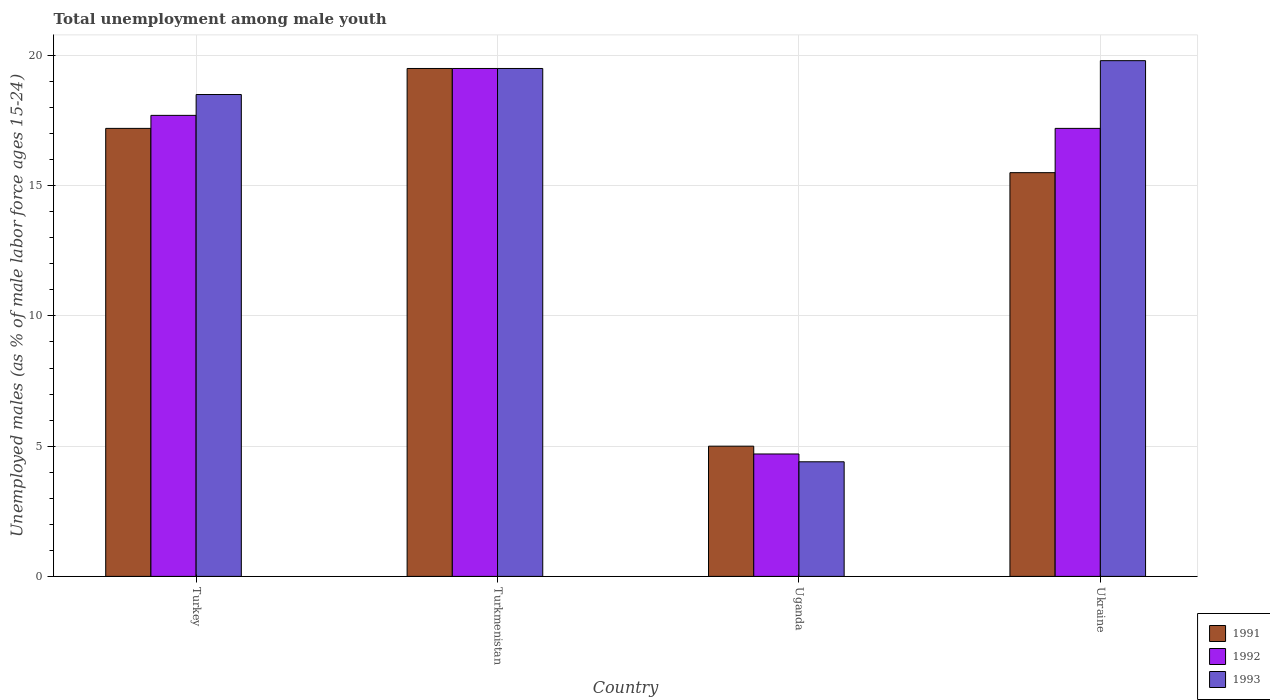How many different coloured bars are there?
Make the answer very short. 3. Are the number of bars per tick equal to the number of legend labels?
Offer a terse response. Yes. What is the label of the 4th group of bars from the left?
Your response must be concise. Ukraine. What is the percentage of unemployed males in in 1993 in Uganda?
Make the answer very short. 4.4. Across all countries, what is the maximum percentage of unemployed males in in 1993?
Your answer should be compact. 19.8. Across all countries, what is the minimum percentage of unemployed males in in 1991?
Give a very brief answer. 5. In which country was the percentage of unemployed males in in 1993 maximum?
Make the answer very short. Ukraine. In which country was the percentage of unemployed males in in 1991 minimum?
Keep it short and to the point. Uganda. What is the total percentage of unemployed males in in 1991 in the graph?
Provide a short and direct response. 57.2. What is the difference between the percentage of unemployed males in in 1992 in Turkey and that in Uganda?
Offer a very short reply. 13. What is the difference between the percentage of unemployed males in in 1991 in Uganda and the percentage of unemployed males in in 1992 in Turkey?
Your answer should be compact. -12.7. What is the average percentage of unemployed males in in 1991 per country?
Provide a succinct answer. 14.3. What is the difference between the percentage of unemployed males in of/in 1993 and percentage of unemployed males in of/in 1991 in Turkmenistan?
Offer a very short reply. 0. In how many countries, is the percentage of unemployed males in in 1991 greater than 14 %?
Your answer should be very brief. 3. What is the ratio of the percentage of unemployed males in in 1993 in Turkmenistan to that in Uganda?
Your answer should be compact. 4.43. What is the difference between the highest and the second highest percentage of unemployed males in in 1993?
Keep it short and to the point. 1. Is the sum of the percentage of unemployed males in in 1993 in Uganda and Ukraine greater than the maximum percentage of unemployed males in in 1992 across all countries?
Your answer should be compact. Yes. What does the 2nd bar from the right in Turkmenistan represents?
Offer a very short reply. 1992. How many bars are there?
Your answer should be very brief. 12. Are the values on the major ticks of Y-axis written in scientific E-notation?
Your answer should be compact. No. Where does the legend appear in the graph?
Ensure brevity in your answer.  Bottom right. How many legend labels are there?
Give a very brief answer. 3. How are the legend labels stacked?
Ensure brevity in your answer.  Vertical. What is the title of the graph?
Offer a very short reply. Total unemployment among male youth. Does "1993" appear as one of the legend labels in the graph?
Offer a terse response. Yes. What is the label or title of the X-axis?
Your answer should be very brief. Country. What is the label or title of the Y-axis?
Offer a very short reply. Unemployed males (as % of male labor force ages 15-24). What is the Unemployed males (as % of male labor force ages 15-24) of 1991 in Turkey?
Keep it short and to the point. 17.2. What is the Unemployed males (as % of male labor force ages 15-24) in 1992 in Turkey?
Offer a very short reply. 17.7. What is the Unemployed males (as % of male labor force ages 15-24) in 1993 in Turkey?
Ensure brevity in your answer.  18.5. What is the Unemployed males (as % of male labor force ages 15-24) in 1992 in Turkmenistan?
Your answer should be compact. 19.5. What is the Unemployed males (as % of male labor force ages 15-24) in 1991 in Uganda?
Ensure brevity in your answer.  5. What is the Unemployed males (as % of male labor force ages 15-24) in 1992 in Uganda?
Offer a very short reply. 4.7. What is the Unemployed males (as % of male labor force ages 15-24) in 1993 in Uganda?
Keep it short and to the point. 4.4. What is the Unemployed males (as % of male labor force ages 15-24) in 1992 in Ukraine?
Keep it short and to the point. 17.2. What is the Unemployed males (as % of male labor force ages 15-24) of 1993 in Ukraine?
Provide a succinct answer. 19.8. Across all countries, what is the maximum Unemployed males (as % of male labor force ages 15-24) of 1993?
Offer a very short reply. 19.8. Across all countries, what is the minimum Unemployed males (as % of male labor force ages 15-24) of 1992?
Provide a succinct answer. 4.7. Across all countries, what is the minimum Unemployed males (as % of male labor force ages 15-24) in 1993?
Provide a succinct answer. 4.4. What is the total Unemployed males (as % of male labor force ages 15-24) of 1991 in the graph?
Your answer should be very brief. 57.2. What is the total Unemployed males (as % of male labor force ages 15-24) in 1992 in the graph?
Provide a succinct answer. 59.1. What is the total Unemployed males (as % of male labor force ages 15-24) in 1993 in the graph?
Your answer should be compact. 62.2. What is the difference between the Unemployed males (as % of male labor force ages 15-24) in 1992 in Turkey and that in Turkmenistan?
Provide a short and direct response. -1.8. What is the difference between the Unemployed males (as % of male labor force ages 15-24) in 1993 in Turkey and that in Turkmenistan?
Give a very brief answer. -1. What is the difference between the Unemployed males (as % of male labor force ages 15-24) of 1993 in Turkey and that in Uganda?
Your answer should be very brief. 14.1. What is the difference between the Unemployed males (as % of male labor force ages 15-24) in 1992 in Turkey and that in Ukraine?
Provide a short and direct response. 0.5. What is the difference between the Unemployed males (as % of male labor force ages 15-24) in 1993 in Turkmenistan and that in Uganda?
Provide a short and direct response. 15.1. What is the difference between the Unemployed males (as % of male labor force ages 15-24) in 1991 in Turkmenistan and that in Ukraine?
Make the answer very short. 4. What is the difference between the Unemployed males (as % of male labor force ages 15-24) of 1992 in Turkmenistan and that in Ukraine?
Give a very brief answer. 2.3. What is the difference between the Unemployed males (as % of male labor force ages 15-24) of 1993 in Uganda and that in Ukraine?
Keep it short and to the point. -15.4. What is the difference between the Unemployed males (as % of male labor force ages 15-24) in 1991 in Turkey and the Unemployed males (as % of male labor force ages 15-24) in 1992 in Turkmenistan?
Provide a short and direct response. -2.3. What is the difference between the Unemployed males (as % of male labor force ages 15-24) of 1991 in Turkey and the Unemployed males (as % of male labor force ages 15-24) of 1992 in Uganda?
Your response must be concise. 12.5. What is the difference between the Unemployed males (as % of male labor force ages 15-24) in 1991 in Turkey and the Unemployed males (as % of male labor force ages 15-24) in 1993 in Uganda?
Ensure brevity in your answer.  12.8. What is the difference between the Unemployed males (as % of male labor force ages 15-24) of 1991 in Turkey and the Unemployed males (as % of male labor force ages 15-24) of 1993 in Ukraine?
Ensure brevity in your answer.  -2.6. What is the difference between the Unemployed males (as % of male labor force ages 15-24) of 1991 in Turkmenistan and the Unemployed males (as % of male labor force ages 15-24) of 1992 in Uganda?
Ensure brevity in your answer.  14.8. What is the difference between the Unemployed males (as % of male labor force ages 15-24) of 1991 in Turkmenistan and the Unemployed males (as % of male labor force ages 15-24) of 1993 in Uganda?
Make the answer very short. 15.1. What is the difference between the Unemployed males (as % of male labor force ages 15-24) of 1992 in Turkmenistan and the Unemployed males (as % of male labor force ages 15-24) of 1993 in Uganda?
Make the answer very short. 15.1. What is the difference between the Unemployed males (as % of male labor force ages 15-24) in 1991 in Turkmenistan and the Unemployed males (as % of male labor force ages 15-24) in 1992 in Ukraine?
Provide a succinct answer. 2.3. What is the difference between the Unemployed males (as % of male labor force ages 15-24) of 1991 in Turkmenistan and the Unemployed males (as % of male labor force ages 15-24) of 1993 in Ukraine?
Make the answer very short. -0.3. What is the difference between the Unemployed males (as % of male labor force ages 15-24) of 1992 in Turkmenistan and the Unemployed males (as % of male labor force ages 15-24) of 1993 in Ukraine?
Your answer should be very brief. -0.3. What is the difference between the Unemployed males (as % of male labor force ages 15-24) of 1991 in Uganda and the Unemployed males (as % of male labor force ages 15-24) of 1992 in Ukraine?
Offer a terse response. -12.2. What is the difference between the Unemployed males (as % of male labor force ages 15-24) in 1991 in Uganda and the Unemployed males (as % of male labor force ages 15-24) in 1993 in Ukraine?
Your response must be concise. -14.8. What is the difference between the Unemployed males (as % of male labor force ages 15-24) in 1992 in Uganda and the Unemployed males (as % of male labor force ages 15-24) in 1993 in Ukraine?
Offer a terse response. -15.1. What is the average Unemployed males (as % of male labor force ages 15-24) in 1992 per country?
Offer a very short reply. 14.78. What is the average Unemployed males (as % of male labor force ages 15-24) in 1993 per country?
Make the answer very short. 15.55. What is the difference between the Unemployed males (as % of male labor force ages 15-24) of 1991 and Unemployed males (as % of male labor force ages 15-24) of 1993 in Turkey?
Your response must be concise. -1.3. What is the difference between the Unemployed males (as % of male labor force ages 15-24) of 1992 and Unemployed males (as % of male labor force ages 15-24) of 1993 in Turkmenistan?
Make the answer very short. 0. What is the difference between the Unemployed males (as % of male labor force ages 15-24) in 1991 and Unemployed males (as % of male labor force ages 15-24) in 1992 in Uganda?
Your answer should be compact. 0.3. What is the difference between the Unemployed males (as % of male labor force ages 15-24) of 1991 and Unemployed males (as % of male labor force ages 15-24) of 1993 in Uganda?
Your answer should be very brief. 0.6. What is the difference between the Unemployed males (as % of male labor force ages 15-24) in 1992 and Unemployed males (as % of male labor force ages 15-24) in 1993 in Ukraine?
Your response must be concise. -2.6. What is the ratio of the Unemployed males (as % of male labor force ages 15-24) in 1991 in Turkey to that in Turkmenistan?
Provide a succinct answer. 0.88. What is the ratio of the Unemployed males (as % of male labor force ages 15-24) of 1992 in Turkey to that in Turkmenistan?
Give a very brief answer. 0.91. What is the ratio of the Unemployed males (as % of male labor force ages 15-24) in 1993 in Turkey to that in Turkmenistan?
Provide a succinct answer. 0.95. What is the ratio of the Unemployed males (as % of male labor force ages 15-24) in 1991 in Turkey to that in Uganda?
Keep it short and to the point. 3.44. What is the ratio of the Unemployed males (as % of male labor force ages 15-24) of 1992 in Turkey to that in Uganda?
Your response must be concise. 3.77. What is the ratio of the Unemployed males (as % of male labor force ages 15-24) in 1993 in Turkey to that in Uganda?
Provide a short and direct response. 4.2. What is the ratio of the Unemployed males (as % of male labor force ages 15-24) in 1991 in Turkey to that in Ukraine?
Keep it short and to the point. 1.11. What is the ratio of the Unemployed males (as % of male labor force ages 15-24) in 1992 in Turkey to that in Ukraine?
Your answer should be compact. 1.03. What is the ratio of the Unemployed males (as % of male labor force ages 15-24) in 1993 in Turkey to that in Ukraine?
Ensure brevity in your answer.  0.93. What is the ratio of the Unemployed males (as % of male labor force ages 15-24) in 1991 in Turkmenistan to that in Uganda?
Ensure brevity in your answer.  3.9. What is the ratio of the Unemployed males (as % of male labor force ages 15-24) in 1992 in Turkmenistan to that in Uganda?
Make the answer very short. 4.15. What is the ratio of the Unemployed males (as % of male labor force ages 15-24) in 1993 in Turkmenistan to that in Uganda?
Offer a terse response. 4.43. What is the ratio of the Unemployed males (as % of male labor force ages 15-24) in 1991 in Turkmenistan to that in Ukraine?
Your answer should be very brief. 1.26. What is the ratio of the Unemployed males (as % of male labor force ages 15-24) in 1992 in Turkmenistan to that in Ukraine?
Your answer should be very brief. 1.13. What is the ratio of the Unemployed males (as % of male labor force ages 15-24) in 1993 in Turkmenistan to that in Ukraine?
Provide a succinct answer. 0.98. What is the ratio of the Unemployed males (as % of male labor force ages 15-24) of 1991 in Uganda to that in Ukraine?
Provide a succinct answer. 0.32. What is the ratio of the Unemployed males (as % of male labor force ages 15-24) in 1992 in Uganda to that in Ukraine?
Keep it short and to the point. 0.27. What is the ratio of the Unemployed males (as % of male labor force ages 15-24) in 1993 in Uganda to that in Ukraine?
Give a very brief answer. 0.22. What is the difference between the highest and the second highest Unemployed males (as % of male labor force ages 15-24) in 1991?
Ensure brevity in your answer.  2.3. What is the difference between the highest and the second highest Unemployed males (as % of male labor force ages 15-24) in 1992?
Your answer should be very brief. 1.8. What is the difference between the highest and the second highest Unemployed males (as % of male labor force ages 15-24) of 1993?
Provide a short and direct response. 0.3. What is the difference between the highest and the lowest Unemployed males (as % of male labor force ages 15-24) of 1992?
Provide a succinct answer. 14.8. 